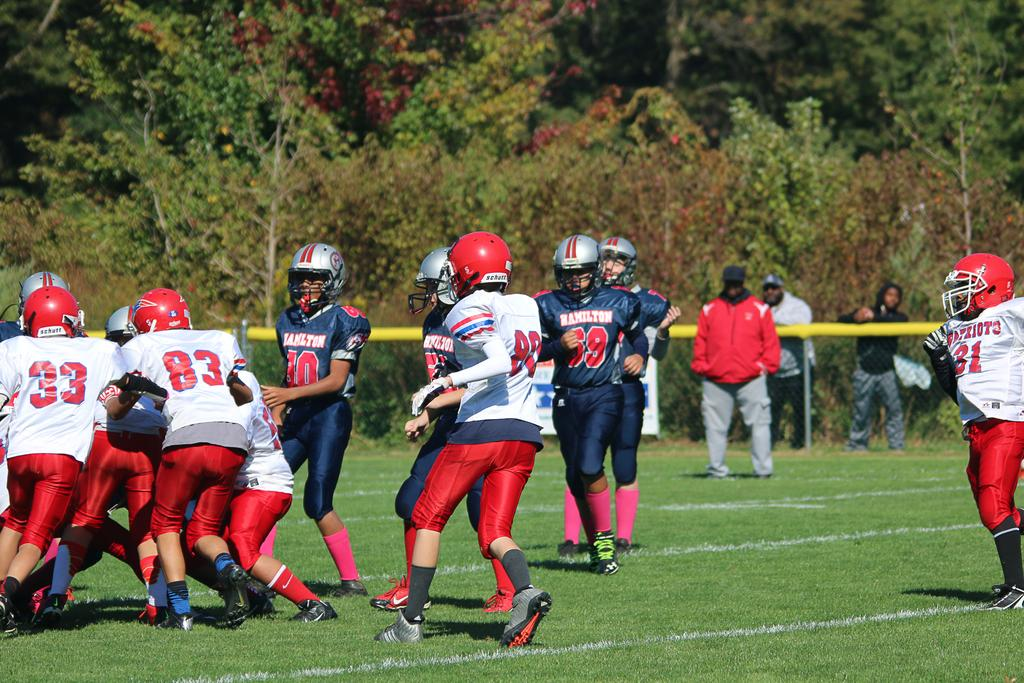What activity are the men in the image engaged in? The men in the image are playing a game. Where is the game being played? The game is being played on grassy land. How many men can be seen in the background of the image? There are three men in the background of the image. What can be seen in the background of the image besides the men? There is a fence and trees in the background of the image. Can you tell me how deep the river is in the image? There is no river present in the image; the game is being played on grassy on grassy land. 